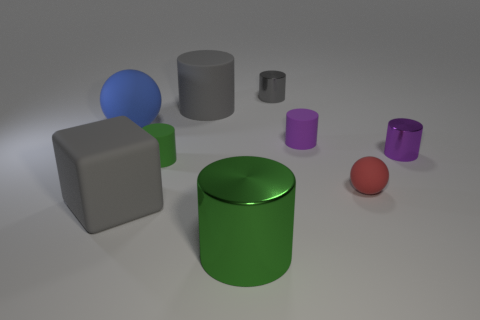What number of metal objects are gray cylinders or large brown things?
Keep it short and to the point. 1. There is a green thing that is the same material as the small gray cylinder; what is its shape?
Offer a terse response. Cylinder. What number of other large things have the same shape as the gray metallic object?
Your response must be concise. 2. There is a gray matte object that is behind the gray block; does it have the same shape as the small object to the right of the red rubber sphere?
Make the answer very short. Yes. How many things are either cylinders or shiny objects in front of the small ball?
Keep it short and to the point. 6. There is a big rubber thing that is the same color as the big matte cube; what is its shape?
Ensure brevity in your answer.  Cylinder. What number of blue matte balls are the same size as the gray metallic object?
Offer a terse response. 0. What number of gray objects are either small balls or big blocks?
Keep it short and to the point. 1. There is a gray rubber object in front of the rubber sphere that is in front of the tiny green matte thing; what shape is it?
Ensure brevity in your answer.  Cube. What is the shape of the gray shiny thing that is the same size as the green rubber cylinder?
Ensure brevity in your answer.  Cylinder. 